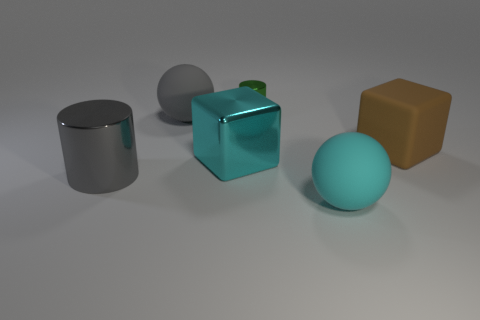Subtract all cylinders. How many objects are left? 4 Subtract all gray balls. How many balls are left? 1 Add 3 tiny green things. How many objects exist? 9 Subtract 2 cubes. How many cubes are left? 0 Add 2 cyan matte objects. How many cyan matte objects are left? 3 Add 4 large gray metal cylinders. How many large gray metal cylinders exist? 5 Subtract 1 cyan cubes. How many objects are left? 5 Subtract all cyan cylinders. Subtract all cyan balls. How many cylinders are left? 2 Subtract all green cylinders. Subtract all tiny blue cylinders. How many objects are left? 5 